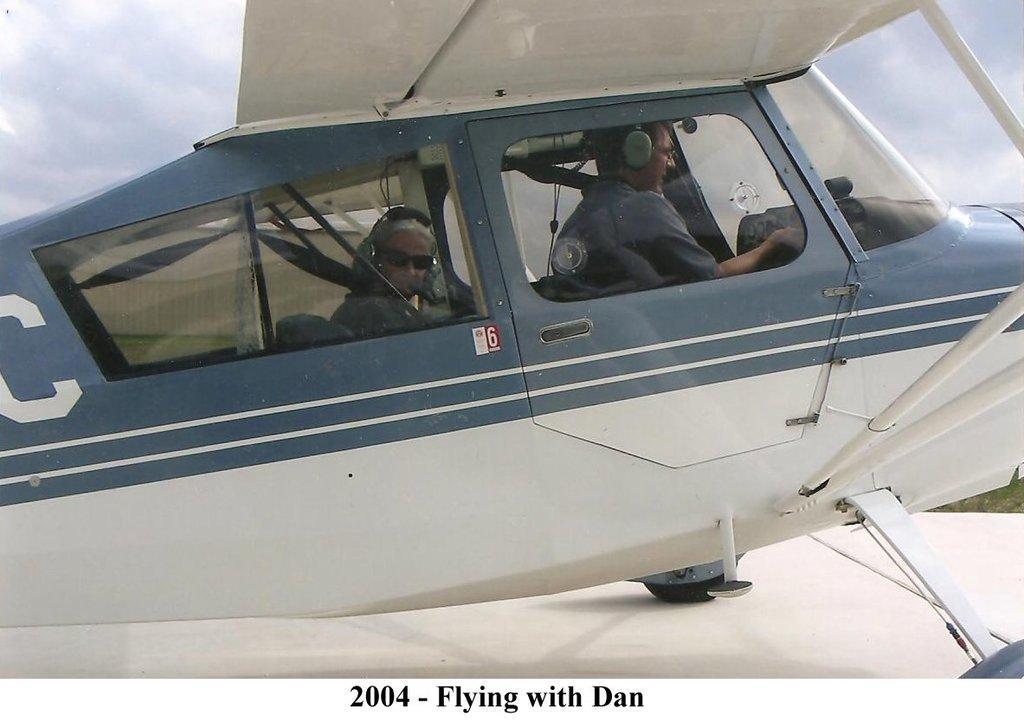Please provide a concise description of this image. In the center of the image we can see persons in aeroplane. In the background we can see sky and clouds. 